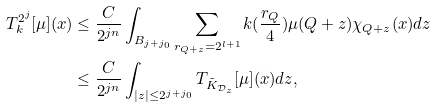Convert formula to latex. <formula><loc_0><loc_0><loc_500><loc_500>T _ { k } ^ { 2 ^ { j } } [ \mu ] ( x ) & \leq \frac { C } { 2 ^ { j n } } \int _ { B _ { j + j _ { 0 } } } \sum _ { r _ { Q + z } = 2 ^ { l + 1 } } k ( \frac { r _ { Q } } 4 ) \mu ( Q + z ) \chi _ { Q + z } ( x ) d z \\ & \leq \frac { C } { 2 ^ { j n } } \int _ { | z | \leq 2 ^ { j + j _ { 0 } } } T _ { \tilde { K } _ { { \mathcal { D } } _ { z } } } [ \mu ] ( x ) d z ,</formula> 